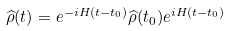Convert formula to latex. <formula><loc_0><loc_0><loc_500><loc_500>\widehat { \rho } ( t ) = e ^ { - i H ( t - t _ { 0 } ) } \widehat { \rho } ( t _ { 0 } ) e ^ { i H ( t - t _ { 0 } ) }</formula> 